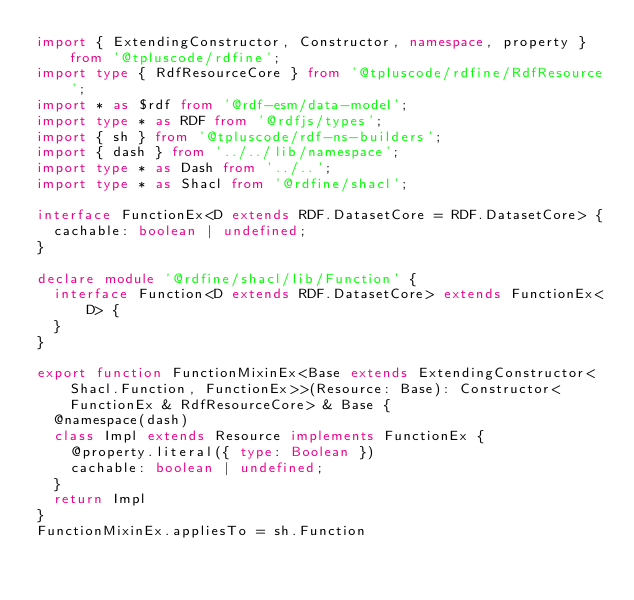Convert code to text. <code><loc_0><loc_0><loc_500><loc_500><_TypeScript_>import { ExtendingConstructor, Constructor, namespace, property } from '@tpluscode/rdfine';
import type { RdfResourceCore } from '@tpluscode/rdfine/RdfResource';
import * as $rdf from '@rdf-esm/data-model';
import type * as RDF from '@rdfjs/types';
import { sh } from '@tpluscode/rdf-ns-builders';
import { dash } from '../../lib/namespace';
import type * as Dash from '../..';
import type * as Shacl from '@rdfine/shacl';

interface FunctionEx<D extends RDF.DatasetCore = RDF.DatasetCore> {
  cachable: boolean | undefined;
}

declare module '@rdfine/shacl/lib/Function' {
  interface Function<D extends RDF.DatasetCore> extends FunctionEx<D> {
  }
}

export function FunctionMixinEx<Base extends ExtendingConstructor<Shacl.Function, FunctionEx>>(Resource: Base): Constructor<FunctionEx & RdfResourceCore> & Base {
  @namespace(dash)
  class Impl extends Resource implements FunctionEx {
    @property.literal({ type: Boolean })
    cachable: boolean | undefined;
  }
  return Impl
}
FunctionMixinEx.appliesTo = sh.Function
</code> 